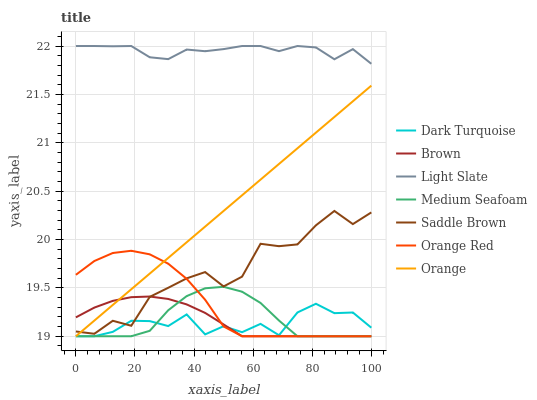Does Dark Turquoise have the minimum area under the curve?
Answer yes or no. Yes. Does Light Slate have the maximum area under the curve?
Answer yes or no. Yes. Does Light Slate have the minimum area under the curve?
Answer yes or no. No. Does Dark Turquoise have the maximum area under the curve?
Answer yes or no. No. Is Orange the smoothest?
Answer yes or no. Yes. Is Saddle Brown the roughest?
Answer yes or no. Yes. Is Light Slate the smoothest?
Answer yes or no. No. Is Light Slate the roughest?
Answer yes or no. No. Does Brown have the lowest value?
Answer yes or no. Yes. Does Light Slate have the lowest value?
Answer yes or no. No. Does Light Slate have the highest value?
Answer yes or no. Yes. Does Dark Turquoise have the highest value?
Answer yes or no. No. Is Orange Red less than Light Slate?
Answer yes or no. Yes. Is Light Slate greater than Orange?
Answer yes or no. Yes. Does Brown intersect Medium Seafoam?
Answer yes or no. Yes. Is Brown less than Medium Seafoam?
Answer yes or no. No. Is Brown greater than Medium Seafoam?
Answer yes or no. No. Does Orange Red intersect Light Slate?
Answer yes or no. No. 